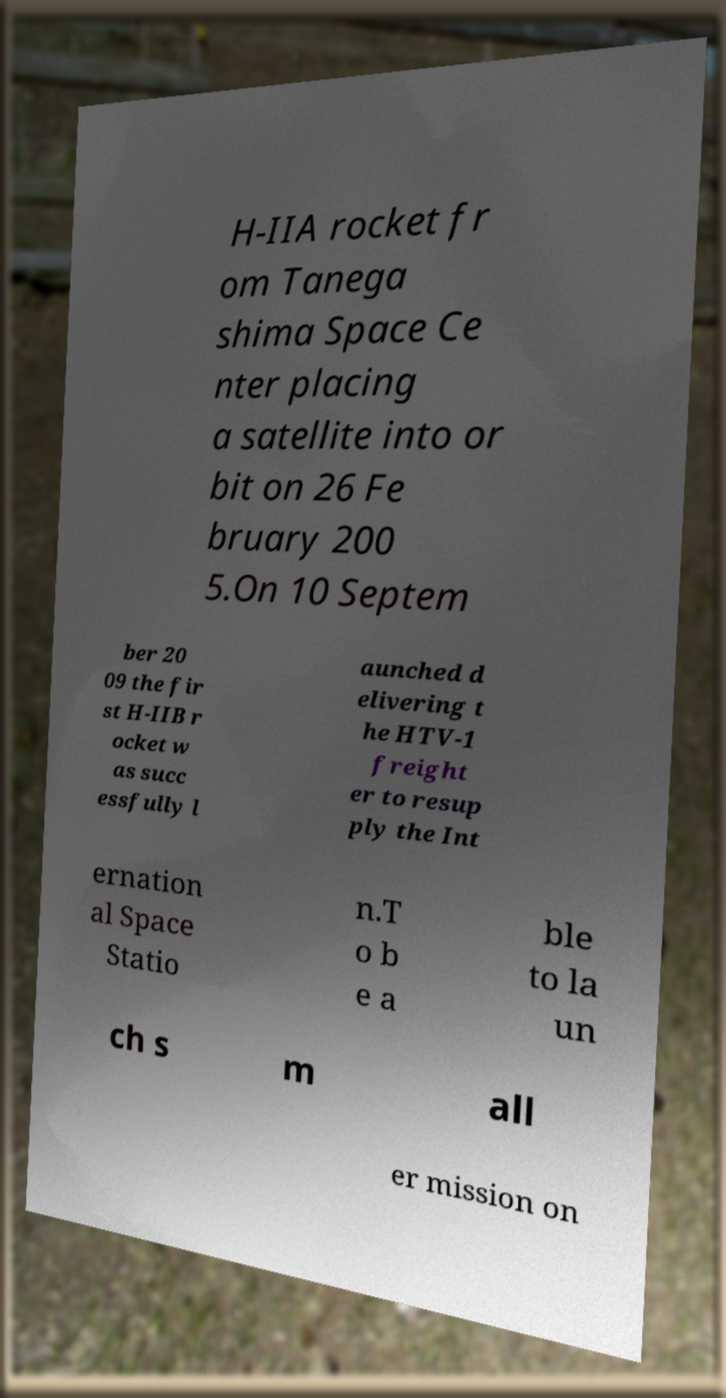Could you assist in decoding the text presented in this image and type it out clearly? H-IIA rocket fr om Tanega shima Space Ce nter placing a satellite into or bit on 26 Fe bruary 200 5.On 10 Septem ber 20 09 the fir st H-IIB r ocket w as succ essfully l aunched d elivering t he HTV-1 freight er to resup ply the Int ernation al Space Statio n.T o b e a ble to la un ch s m all er mission on 